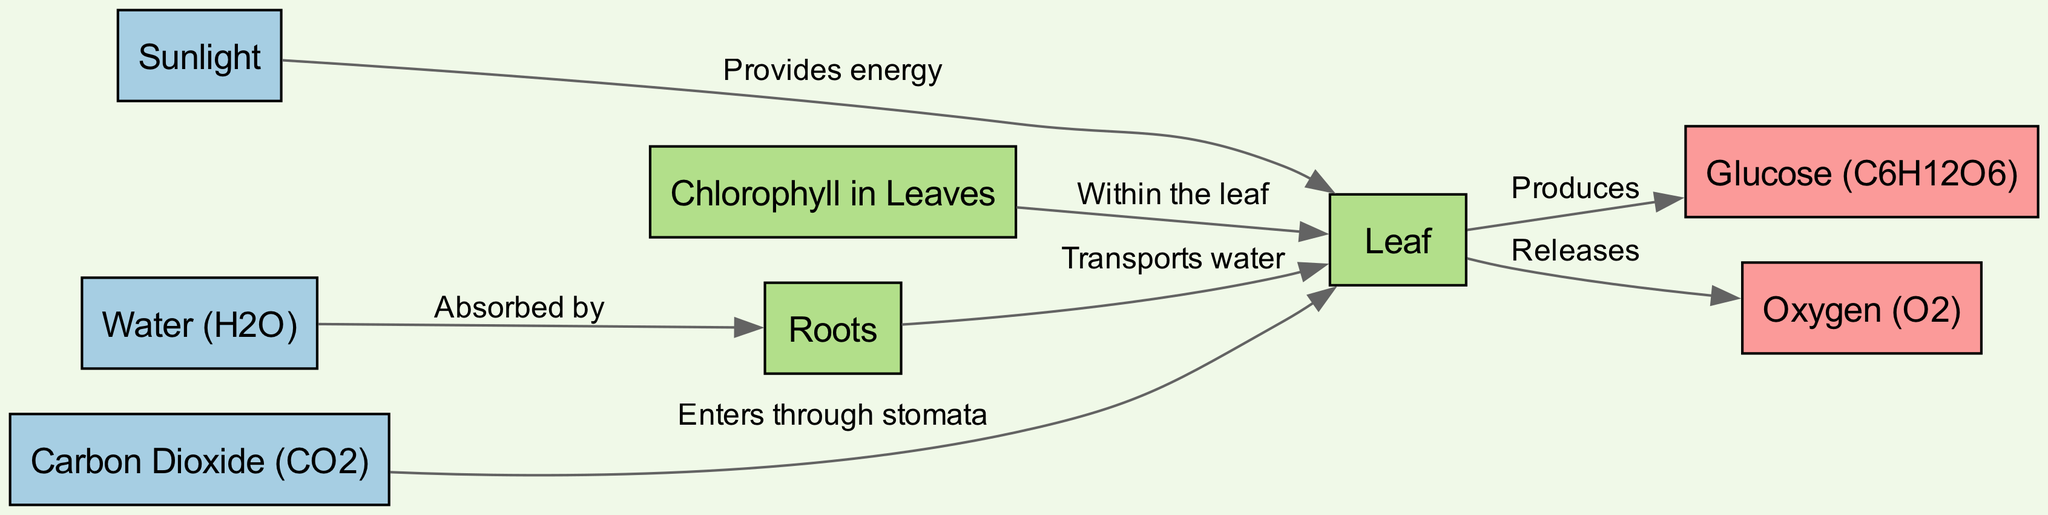What are the inputs in the photosynthesis process? In the diagram, the input nodes are listed as Sunlight, Water (H2O), and Carbon Dioxide (CO2). These nodes are designated as input types, which means they are necessary for the process to occur.
Answer: Sunlight, Water (H2O), Carbon Dioxide (CO2) How many output nodes are present in the diagram? The output nodes are Glucose (C6H12O6) and Oxygen (O2). By counting these nodes, we find that there are two output nodes in the diagram.
Answer: 2 What does Chlorophyll do in the leaf? The diagram shows that Chlorophyll is located within the leaf and plays a crucial role in the photosynthesis process. It is involved in capturing sunlight, which provides the energy needed for this process.
Answer: Within the leaf What role do roots play in photosynthesis? The diagram indicates that roots absorb water and transport it to the leaf. This process is vital because water is one of the inputs needed for photosynthesis.
Answer: Absorb water and transport to the leaf How is carbon dioxide introduced into the leaf? According to the diagram, carbon dioxide enters the leaf through the stomata, which are small openings on the leaf surface. This is a critical step as CO2 is essential for the production of glucose.
Answer: Enters through stomata Which output is released during photosynthesis? The diagram displays that during the process of photosynthesis, the leaf releases oxygen. This is a byproduct of the entire conversion process happening within the leaf.
Answer: Oxygen (O2) What is produced as a result of photosynthesis? The diagram states that glucose is produced within the leaf as a result of the photosynthesis process. This indicates the transformation of light energy into chemical energy stored in glucose.
Answer: Glucose (C6H12O6) What provides energy for the photosynthesis process? The diagram illustrates that sunlight provides the energy necessary for photosynthesis. This input is crucial as it energizes the process that takes place in the leaves.
Answer: Sunlight What is the function of leaves in this process? The diagram identifies the leaf as a component where several processes occur, including the absorption of sunlight, CO2 intake, and production of glucose and oxygen, thereby making the leaf integral to photosynthesis.
Answer: Photosynthesis occurs here 